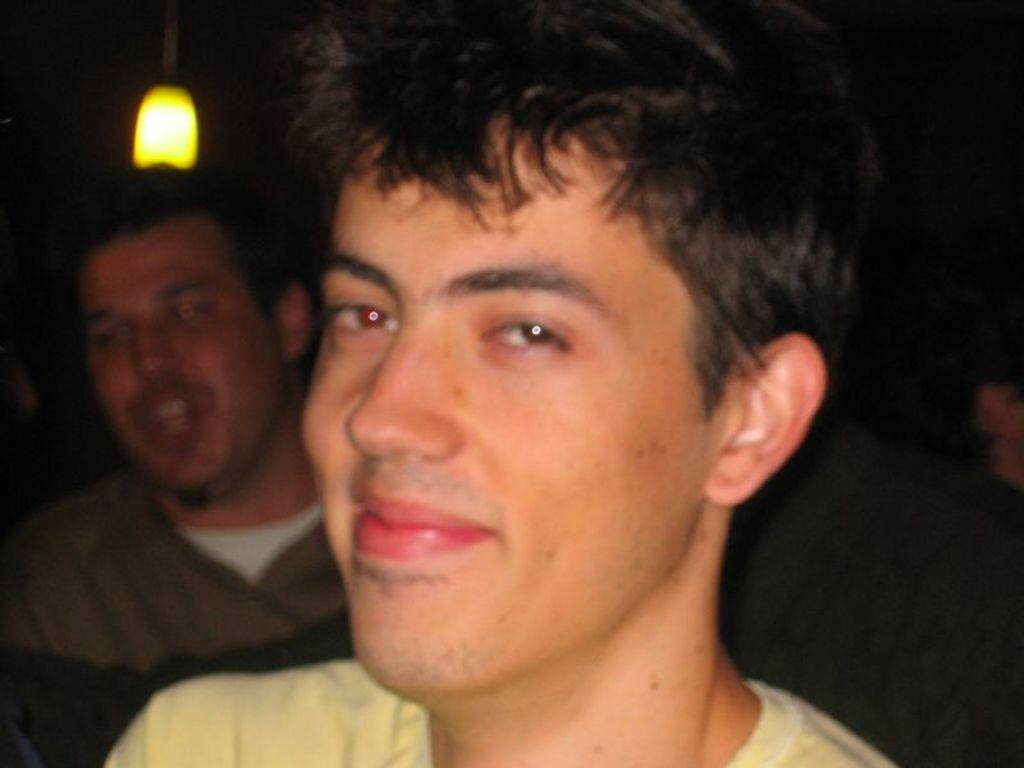Who or what is present in the image? There are people in the image. What can be seen providing illumination in the image? There is a light visible in the image. What can be inferred about the lighting conditions in the image? The background of the image appears to be dark. How many cannons are being used by the people in the image? There are no cannons present in the image. What type of rabbits can be seen interacting with the people in the image? There are no rabbits present in the image. 